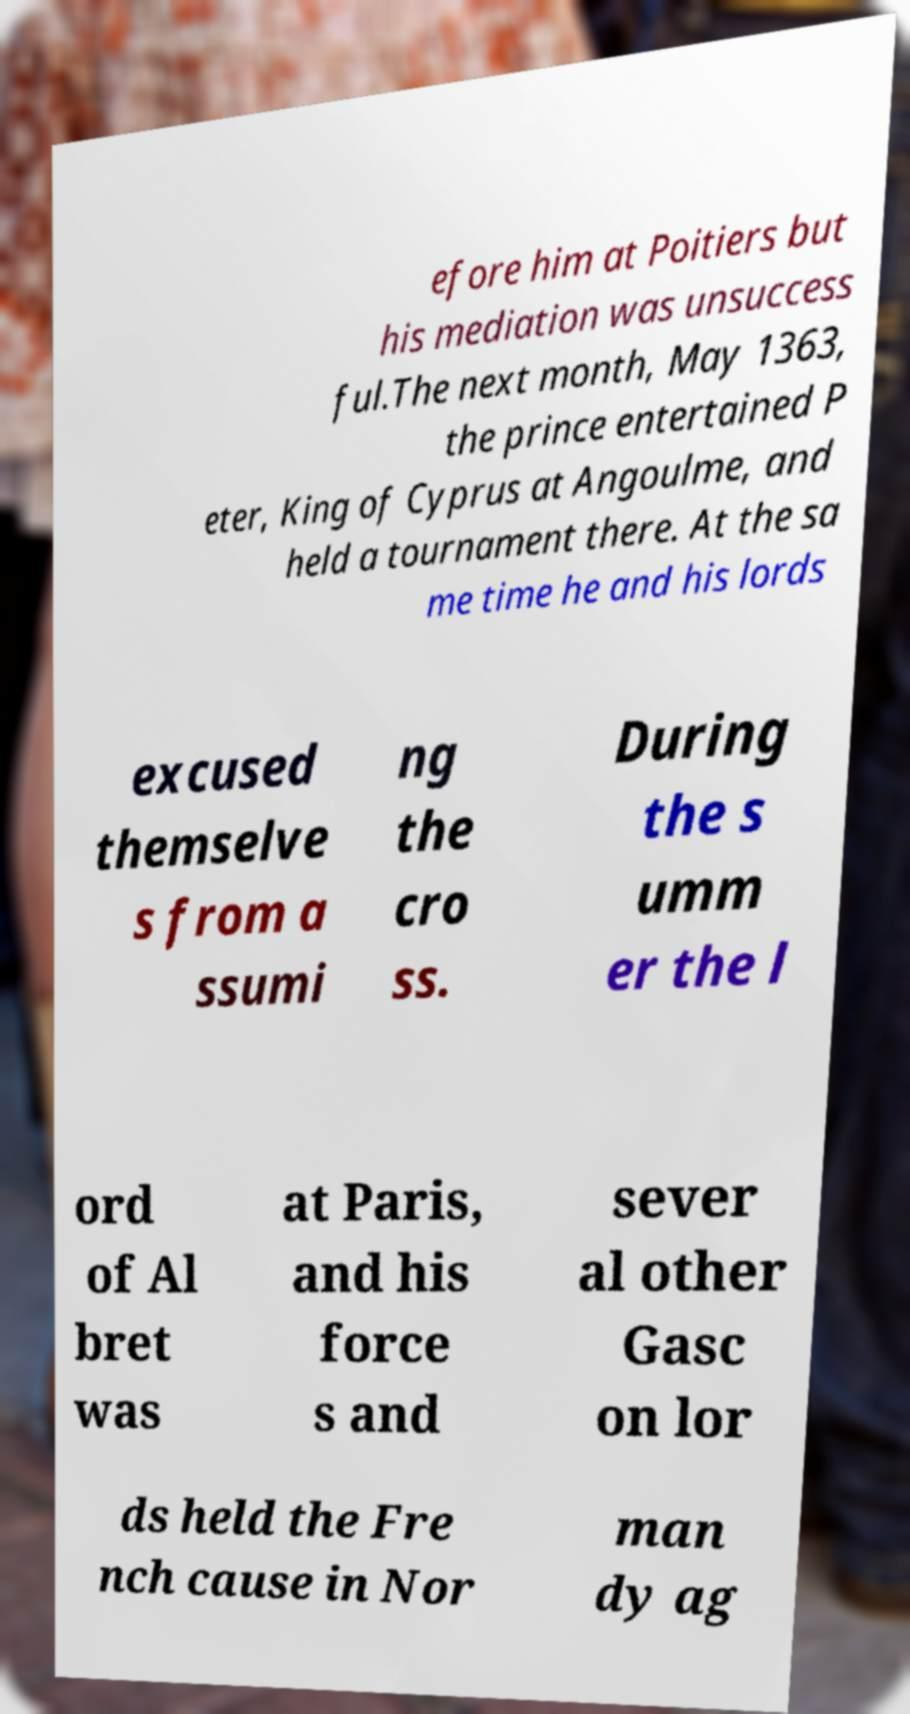What messages or text are displayed in this image? I need them in a readable, typed format. efore him at Poitiers but his mediation was unsuccess ful.The next month, May 1363, the prince entertained P eter, King of Cyprus at Angoulme, and held a tournament there. At the sa me time he and his lords excused themselve s from a ssumi ng the cro ss. During the s umm er the l ord of Al bret was at Paris, and his force s and sever al other Gasc on lor ds held the Fre nch cause in Nor man dy ag 